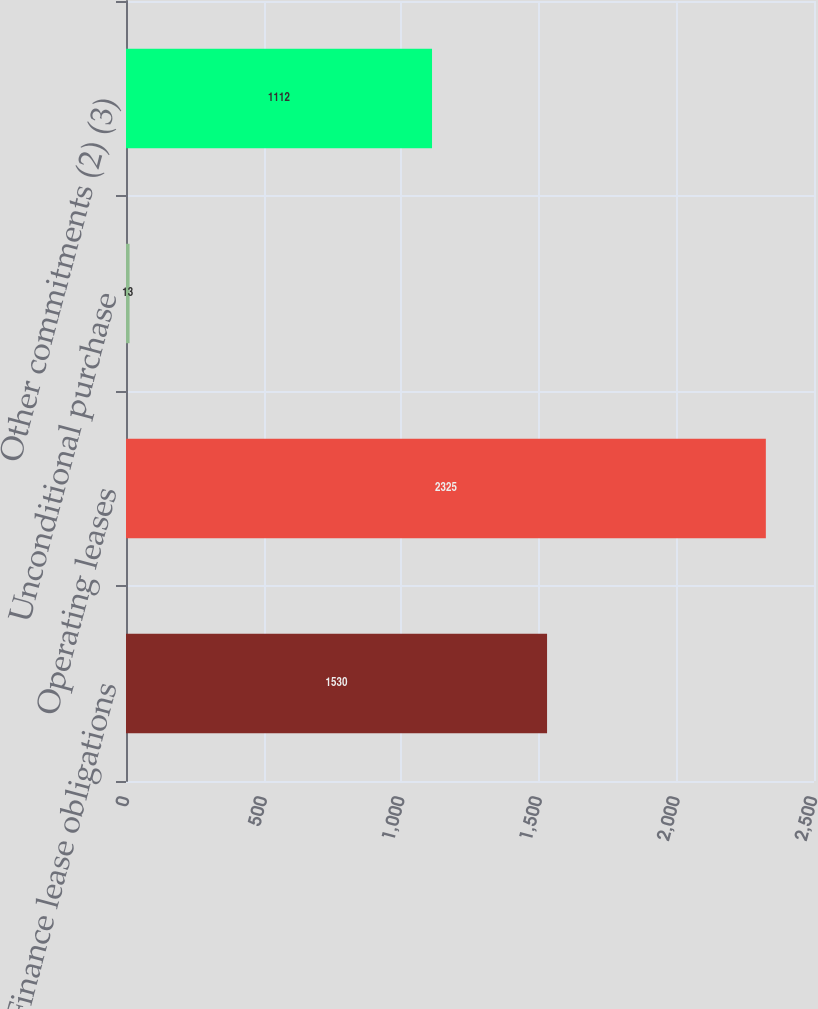<chart> <loc_0><loc_0><loc_500><loc_500><bar_chart><fcel>Finance lease obligations<fcel>Operating leases<fcel>Unconditional purchase<fcel>Other commitments (2) (3)<nl><fcel>1530<fcel>2325<fcel>13<fcel>1112<nl></chart> 